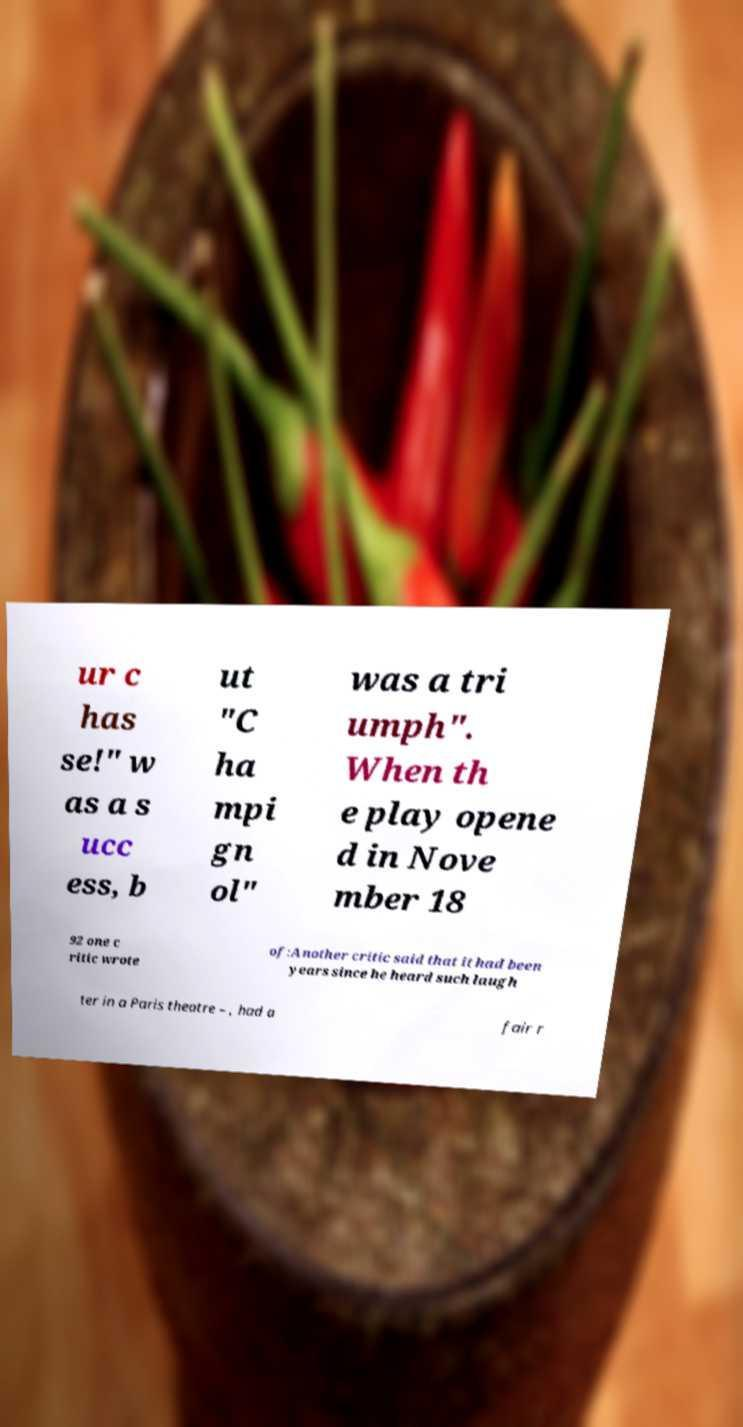Can you accurately transcribe the text from the provided image for me? ur c has se!" w as a s ucc ess, b ut "C ha mpi gn ol" was a tri umph". When th e play opene d in Nove mber 18 92 one c ritic wrote of:Another critic said that it had been years since he heard such laugh ter in a Paris theatre – , had a fair r 